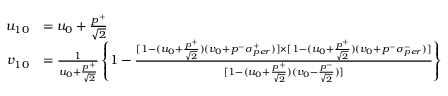Convert formula to latex. <formula><loc_0><loc_0><loc_500><loc_500>\begin{array} { r l } { { u _ { 1 0 } } } & { { = u _ { 0 } + \frac { p ^ { + } } { \sqrt { 2 } } } } \\ { { v _ { 1 0 } } } & { { = \frac { 1 } { u _ { 0 } + \frac { p ^ { + } } { \sqrt { 2 } } } \left \{ 1 - \frac { [ 1 - ( u _ { 0 } + \frac { p ^ { + } } { \sqrt { 2 } } ) ( v _ { 0 } + p ^ { - } \sigma _ { p e r } ^ { + } ) ] \times [ 1 - ( u _ { 0 } + \frac { p ^ { + } } { \sqrt { 2 } } ) ( v _ { 0 } + p ^ { - } \sigma _ { p e r } ^ { - } ) ] } { [ 1 - ( u _ { 0 } + \frac { p ^ { + } } { \sqrt { 2 } } ) ( v _ { 0 } - \frac { p ^ { - } } { \sqrt { 2 } } ) ] } \right \} } } \end{array}</formula> 